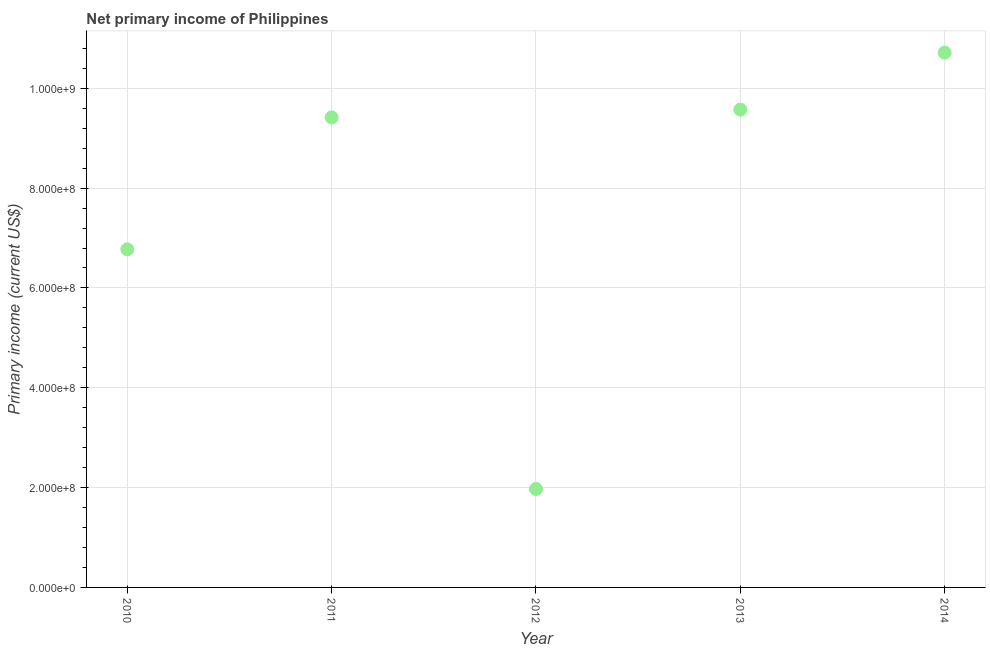What is the amount of primary income in 2012?
Keep it short and to the point. 1.97e+08. Across all years, what is the maximum amount of primary income?
Provide a succinct answer. 1.07e+09. Across all years, what is the minimum amount of primary income?
Your answer should be compact. 1.97e+08. In which year was the amount of primary income maximum?
Provide a succinct answer. 2014. In which year was the amount of primary income minimum?
Provide a succinct answer. 2012. What is the sum of the amount of primary income?
Offer a terse response. 3.85e+09. What is the difference between the amount of primary income in 2012 and 2013?
Provide a short and direct response. -7.60e+08. What is the average amount of primary income per year?
Offer a terse response. 7.69e+08. What is the median amount of primary income?
Give a very brief answer. 9.42e+08. In how many years, is the amount of primary income greater than 520000000 US$?
Your answer should be compact. 4. What is the ratio of the amount of primary income in 2010 to that in 2012?
Ensure brevity in your answer.  3.43. Is the difference between the amount of primary income in 2010 and 2012 greater than the difference between any two years?
Make the answer very short. No. What is the difference between the highest and the second highest amount of primary income?
Keep it short and to the point. 1.14e+08. What is the difference between the highest and the lowest amount of primary income?
Provide a succinct answer. 8.74e+08. In how many years, is the amount of primary income greater than the average amount of primary income taken over all years?
Offer a terse response. 3. How many years are there in the graph?
Give a very brief answer. 5. Does the graph contain any zero values?
Your answer should be compact. No. Does the graph contain grids?
Your answer should be very brief. Yes. What is the title of the graph?
Ensure brevity in your answer.  Net primary income of Philippines. What is the label or title of the Y-axis?
Ensure brevity in your answer.  Primary income (current US$). What is the Primary income (current US$) in 2010?
Provide a short and direct response. 6.77e+08. What is the Primary income (current US$) in 2011?
Ensure brevity in your answer.  9.42e+08. What is the Primary income (current US$) in 2012?
Your answer should be compact. 1.97e+08. What is the Primary income (current US$) in 2013?
Give a very brief answer. 9.57e+08. What is the Primary income (current US$) in 2014?
Give a very brief answer. 1.07e+09. What is the difference between the Primary income (current US$) in 2010 and 2011?
Give a very brief answer. -2.64e+08. What is the difference between the Primary income (current US$) in 2010 and 2012?
Make the answer very short. 4.80e+08. What is the difference between the Primary income (current US$) in 2010 and 2013?
Your answer should be compact. -2.80e+08. What is the difference between the Primary income (current US$) in 2010 and 2014?
Your answer should be compact. -3.94e+08. What is the difference between the Primary income (current US$) in 2011 and 2012?
Provide a succinct answer. 7.45e+08. What is the difference between the Primary income (current US$) in 2011 and 2013?
Provide a succinct answer. -1.56e+07. What is the difference between the Primary income (current US$) in 2011 and 2014?
Offer a very short reply. -1.30e+08. What is the difference between the Primary income (current US$) in 2012 and 2013?
Your response must be concise. -7.60e+08. What is the difference between the Primary income (current US$) in 2012 and 2014?
Provide a succinct answer. -8.74e+08. What is the difference between the Primary income (current US$) in 2013 and 2014?
Make the answer very short. -1.14e+08. What is the ratio of the Primary income (current US$) in 2010 to that in 2011?
Offer a terse response. 0.72. What is the ratio of the Primary income (current US$) in 2010 to that in 2012?
Your answer should be compact. 3.44. What is the ratio of the Primary income (current US$) in 2010 to that in 2013?
Your response must be concise. 0.71. What is the ratio of the Primary income (current US$) in 2010 to that in 2014?
Provide a succinct answer. 0.63. What is the ratio of the Primary income (current US$) in 2011 to that in 2012?
Your answer should be compact. 4.78. What is the ratio of the Primary income (current US$) in 2011 to that in 2014?
Offer a very short reply. 0.88. What is the ratio of the Primary income (current US$) in 2012 to that in 2013?
Offer a very short reply. 0.21. What is the ratio of the Primary income (current US$) in 2012 to that in 2014?
Keep it short and to the point. 0.18. What is the ratio of the Primary income (current US$) in 2013 to that in 2014?
Your response must be concise. 0.89. 